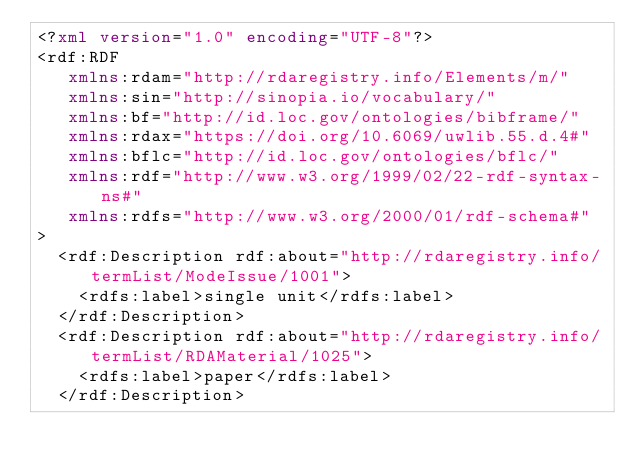<code> <loc_0><loc_0><loc_500><loc_500><_XML_><?xml version="1.0" encoding="UTF-8"?>
<rdf:RDF
   xmlns:rdam="http://rdaregistry.info/Elements/m/"
   xmlns:sin="http://sinopia.io/vocabulary/"
   xmlns:bf="http://id.loc.gov/ontologies/bibframe/"
   xmlns:rdax="https://doi.org/10.6069/uwlib.55.d.4#"
   xmlns:bflc="http://id.loc.gov/ontologies/bflc/"
   xmlns:rdf="http://www.w3.org/1999/02/22-rdf-syntax-ns#"
   xmlns:rdfs="http://www.w3.org/2000/01/rdf-schema#"
>
  <rdf:Description rdf:about="http://rdaregistry.info/termList/ModeIssue/1001">
    <rdfs:label>single unit</rdfs:label>
  </rdf:Description>
  <rdf:Description rdf:about="http://rdaregistry.info/termList/RDAMaterial/1025">
    <rdfs:label>paper</rdfs:label>
  </rdf:Description></code> 